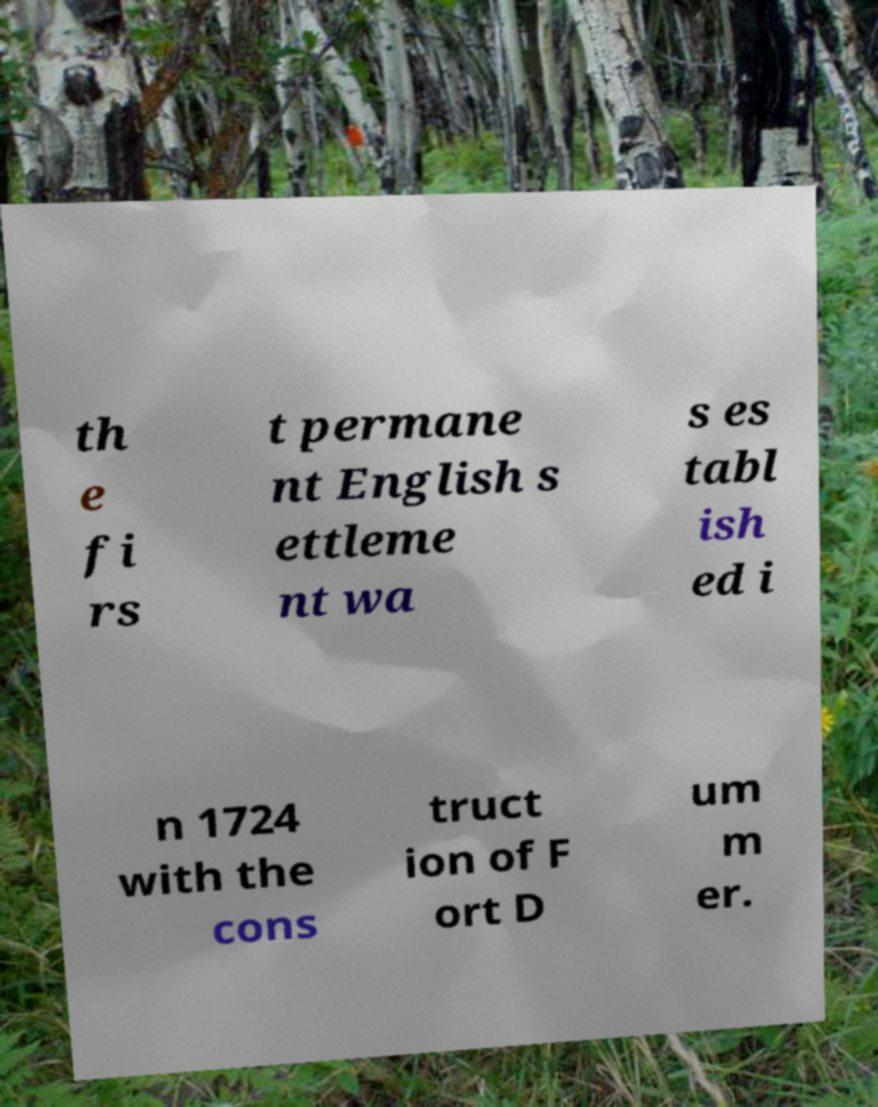Please identify and transcribe the text found in this image. th e fi rs t permane nt English s ettleme nt wa s es tabl ish ed i n 1724 with the cons truct ion of F ort D um m er. 